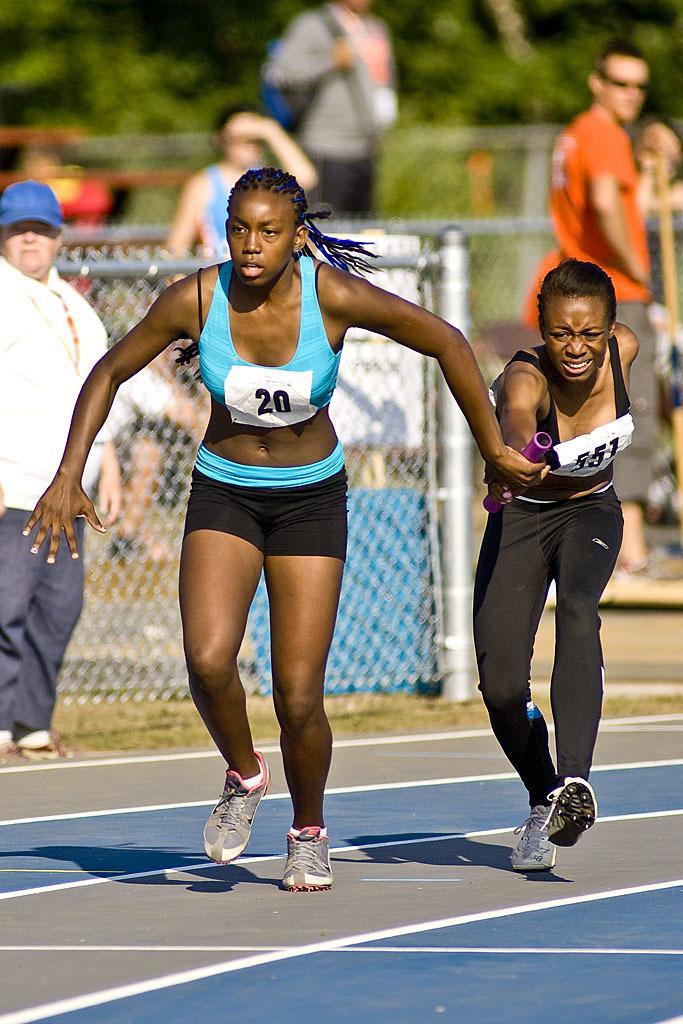Could you give a brief overview of what you see in this image? In this image, we can see two women running and holding an object. In the background, we can see the meshes, people and blur view. 